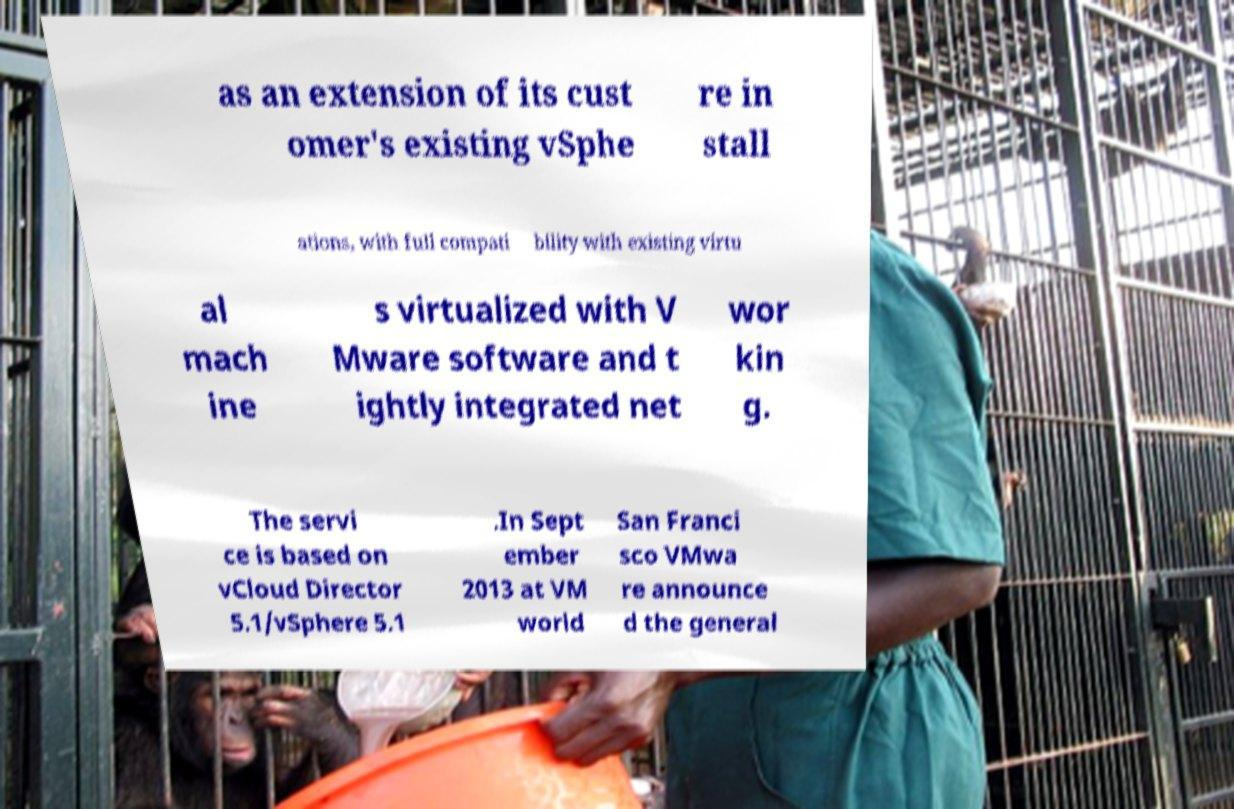Please identify and transcribe the text found in this image. as an extension of its cust omer's existing vSphe re in stall ations, with full compati bility with existing virtu al mach ine s virtualized with V Mware software and t ightly integrated net wor kin g. The servi ce is based on vCloud Director 5.1/vSphere 5.1 .In Sept ember 2013 at VM world San Franci sco VMwa re announce d the general 